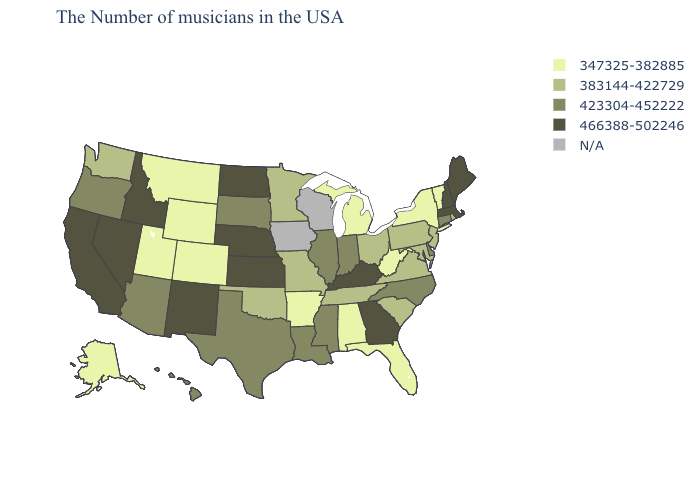What is the lowest value in states that border Arizona?
Short answer required. 347325-382885. Name the states that have a value in the range 383144-422729?
Answer briefly. Rhode Island, New Jersey, Maryland, Pennsylvania, Virginia, South Carolina, Ohio, Tennessee, Missouri, Minnesota, Oklahoma, Washington. What is the lowest value in the USA?
Short answer required. 347325-382885. What is the value of Ohio?
Be succinct. 383144-422729. What is the value of Vermont?
Quick response, please. 347325-382885. What is the highest value in the MidWest ?
Answer briefly. 466388-502246. Among the states that border Connecticut , which have the lowest value?
Keep it brief. New York. How many symbols are there in the legend?
Concise answer only. 5. Name the states that have a value in the range 466388-502246?
Keep it brief. Maine, Massachusetts, New Hampshire, Georgia, Kentucky, Kansas, Nebraska, North Dakota, New Mexico, Idaho, Nevada, California. Name the states that have a value in the range 423304-452222?
Give a very brief answer. Connecticut, Delaware, North Carolina, Indiana, Illinois, Mississippi, Louisiana, Texas, South Dakota, Arizona, Oregon, Hawaii. What is the value of Hawaii?
Quick response, please. 423304-452222. What is the lowest value in states that border Washington?
Give a very brief answer. 423304-452222. Does Minnesota have the lowest value in the USA?
Concise answer only. No. 